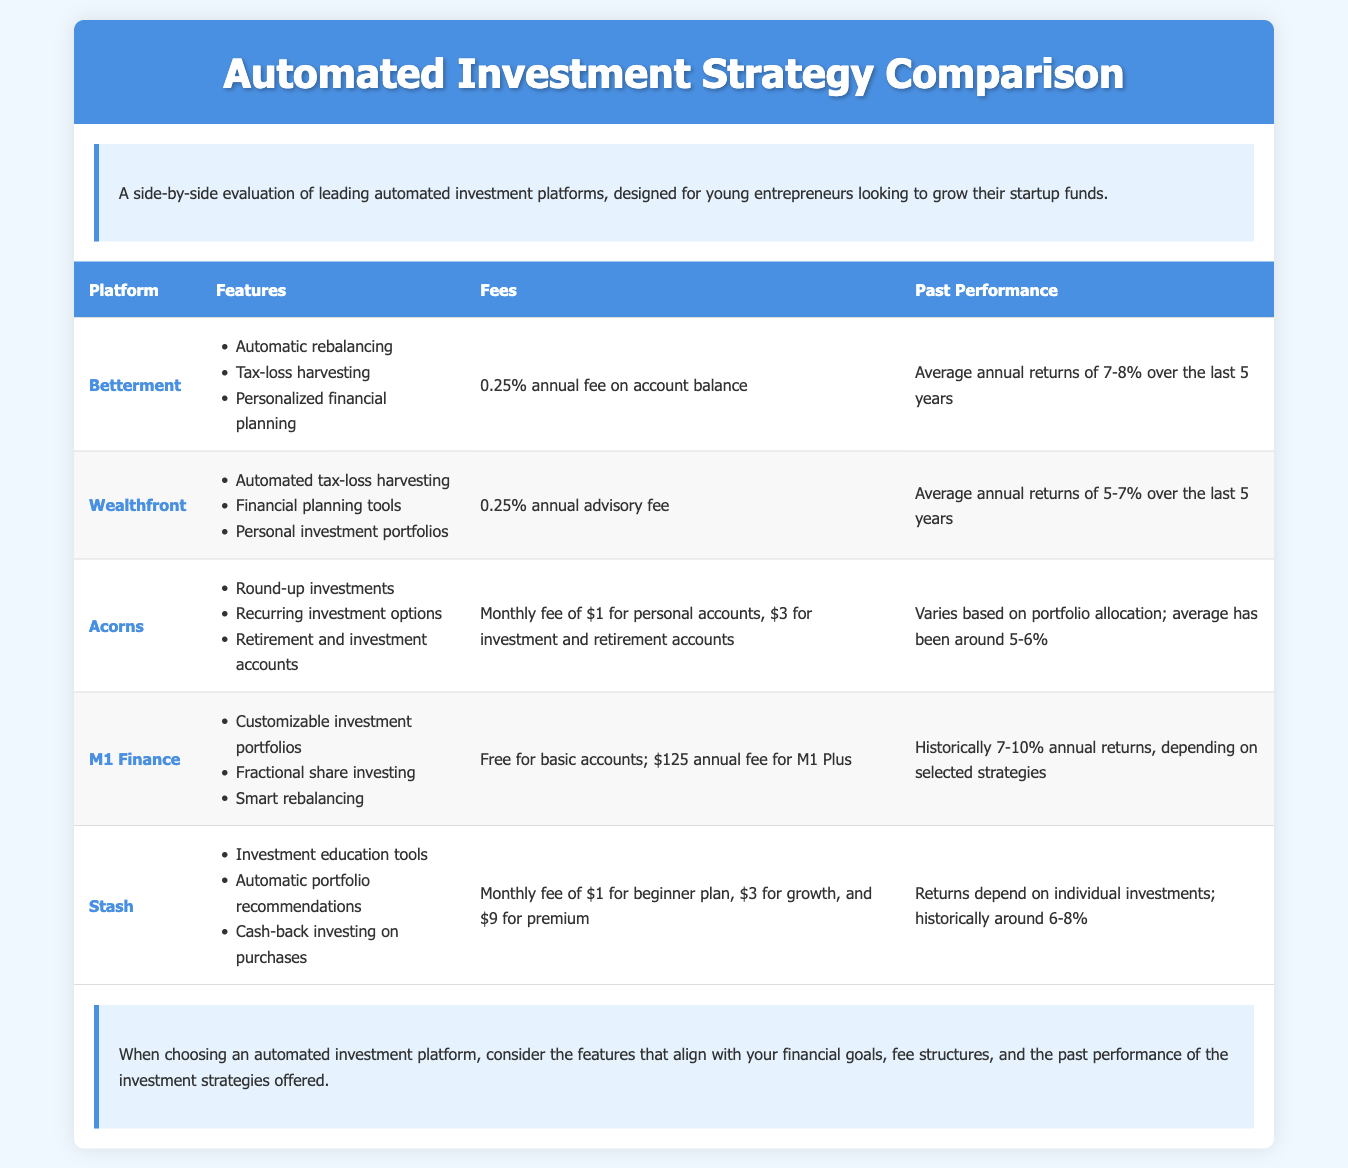What is Betterment's annual fee? Betterment charges a 0.25% annual fee on the account balance.
Answer: 0.25% What type of accounts does Acorns offer? Acorns provides retirement and investment accounts as part of their features.
Answer: Retirement and investment accounts What is M1 Finance's historical annual returns? M1 Finance has historically provided annual returns between 7-10%, depending on selected strategies.
Answer: 7-10% How many platforms are compared in the document? The document compares five automated investment platforms.
Answer: Five Which platform offers round-up investments? Acorns is the platform that offers round-up investments as a feature.
Answer: Acorns What is the monthly fee for Stash's beginner plan? Stash charges a monthly fee of $1 for the beginner plan.
Answer: $1 What is the past performance return range for Wealthfront? Wealthfront has average annual returns of 5-7% over the last 5 years.
Answer: 5-7% What is one feature of Betterment? One of the features of Betterment is automatic rebalancing.
Answer: Automatic rebalancing What is the annual fee for M1 Plus? The annual fee for M1 Plus is $125.
Answer: $125 